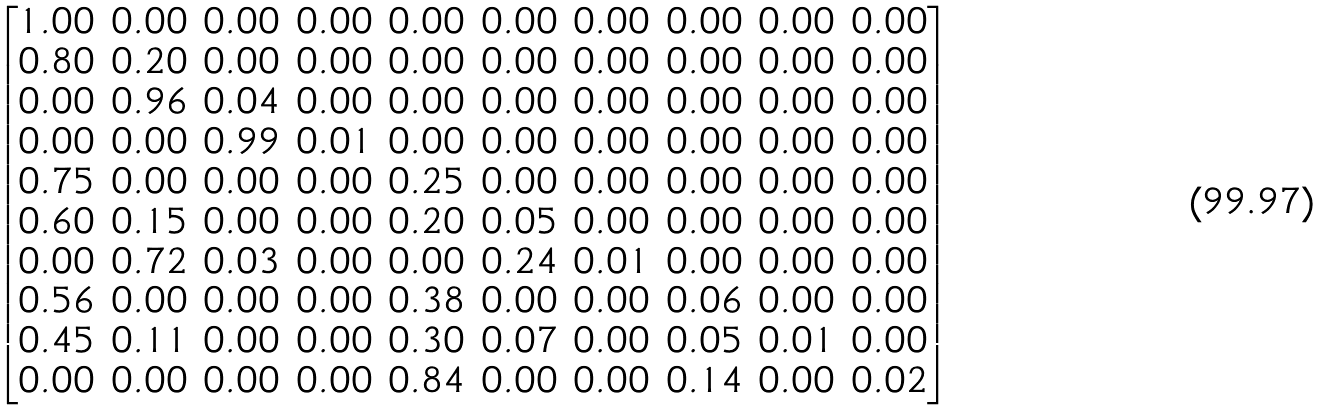<formula> <loc_0><loc_0><loc_500><loc_500>\begin{bmatrix} 1 . 0 0 & 0 . 0 0 & 0 . 0 0 & 0 . 0 0 & 0 . 0 0 & 0 . 0 0 & 0 . 0 0 & 0 . 0 0 & 0 . 0 0 & 0 . 0 0 \\ 0 . 8 0 & 0 . 2 0 & 0 . 0 0 & 0 . 0 0 & 0 . 0 0 & 0 . 0 0 & 0 . 0 0 & 0 . 0 0 & 0 . 0 0 & 0 . 0 0 \\ 0 . 0 0 & 0 . 9 6 & 0 . 0 4 & 0 . 0 0 & 0 . 0 0 & 0 . 0 0 & 0 . 0 0 & 0 . 0 0 & 0 . 0 0 & 0 . 0 0 \\ 0 . 0 0 & 0 . 0 0 & 0 . 9 9 & 0 . 0 1 & 0 . 0 0 & 0 . 0 0 & 0 . 0 0 & 0 . 0 0 & 0 . 0 0 & 0 . 0 0 \\ 0 . 7 5 & 0 . 0 0 & 0 . 0 0 & 0 . 0 0 & 0 . 2 5 & 0 . 0 0 & 0 . 0 0 & 0 . 0 0 & 0 . 0 0 & 0 . 0 0 \\ 0 . 6 0 & 0 . 1 5 & 0 . 0 0 & 0 . 0 0 & 0 . 2 0 & 0 . 0 5 & 0 . 0 0 & 0 . 0 0 & 0 . 0 0 & 0 . 0 0 \\ 0 . 0 0 & 0 . 7 2 & 0 . 0 3 & 0 . 0 0 & 0 . 0 0 & 0 . 2 4 & 0 . 0 1 & 0 . 0 0 & 0 . 0 0 & 0 . 0 0 \\ 0 . 5 6 & 0 . 0 0 & 0 . 0 0 & 0 . 0 0 & 0 . 3 8 & 0 . 0 0 & 0 . 0 0 & 0 . 0 6 & 0 . 0 0 & 0 . 0 0 \\ 0 . 4 5 & 0 . 1 1 & 0 . 0 0 & 0 . 0 0 & 0 . 3 0 & 0 . 0 7 & 0 . 0 0 & 0 . 0 5 & 0 . 0 1 & 0 . 0 0 \\ 0 . 0 0 & 0 . 0 0 & 0 . 0 0 & 0 . 0 0 & 0 . 8 4 & 0 . 0 0 & 0 . 0 0 & 0 . 1 4 & 0 . 0 0 & 0 . 0 2 \end{bmatrix}</formula> 